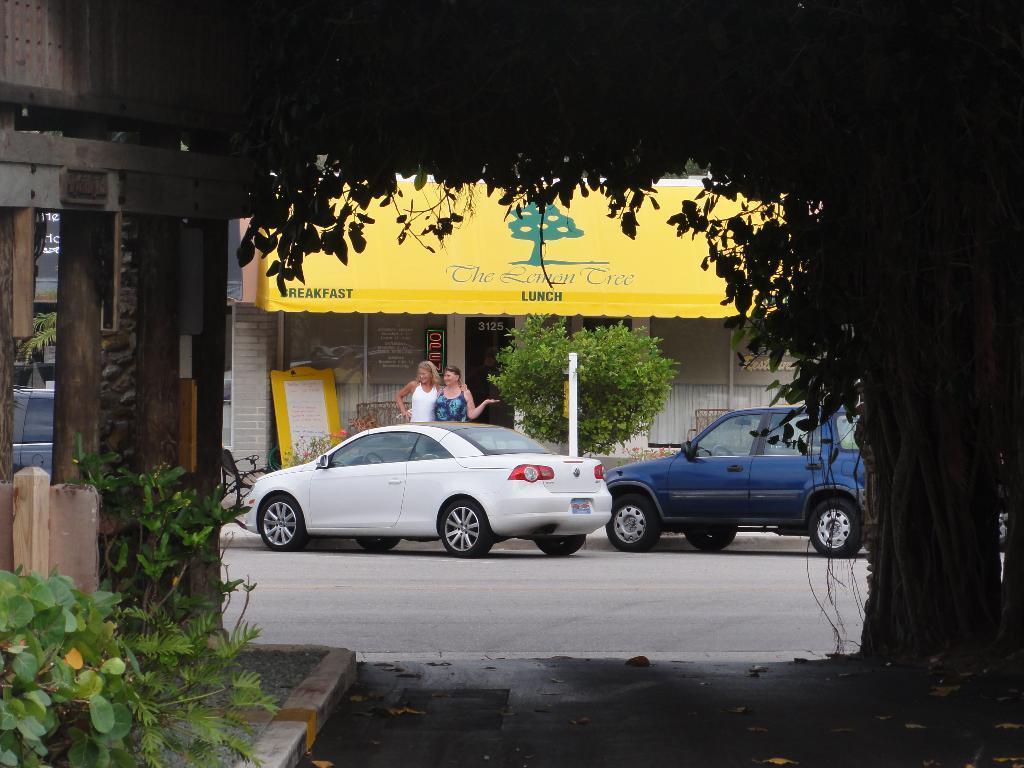Describe this image in one or two sentences. At the bottom, we see the road. On the left side, we see the plants, wooden poles and a building. In the middle, we see the cars parked on the road. Beside that, we see a pole, tree and two women are standing. Beside them, we see a board in yellow and white color with some text written on it. Behind them, we see a building with a yellow color roof. On the right side, we see a tree. This picture is clicked outside the city. 